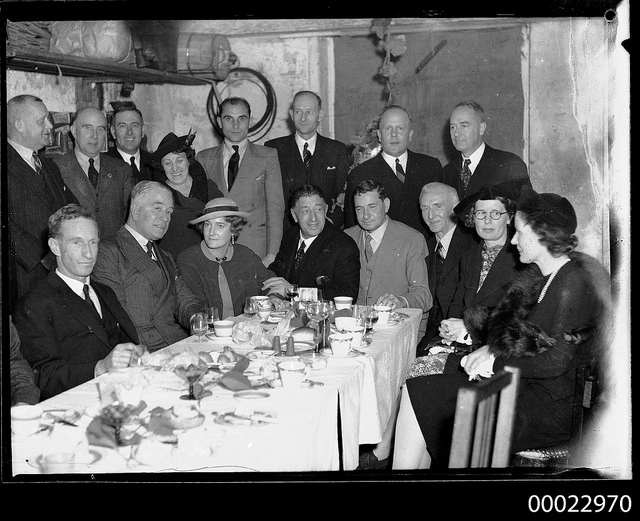<image>Is the same little girl in the photos? It is ambiguous if the same little girl is in the photos. Is the same little girl in the photos? It is unanswerable if the same little girl is in the photos. It can be both the same girl or different girls. 